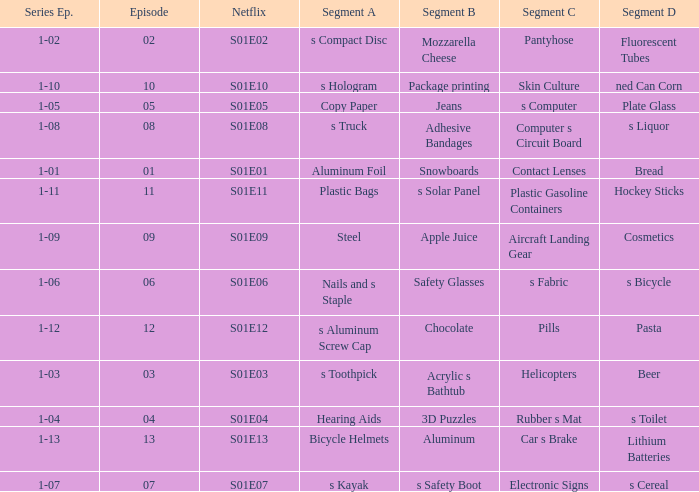What is the segment A name, having a Netflix of s01e12? S aluminum screw cap. 